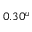<formula> <loc_0><loc_0><loc_500><loc_500>0 . 3 0 ^ { u }</formula> 